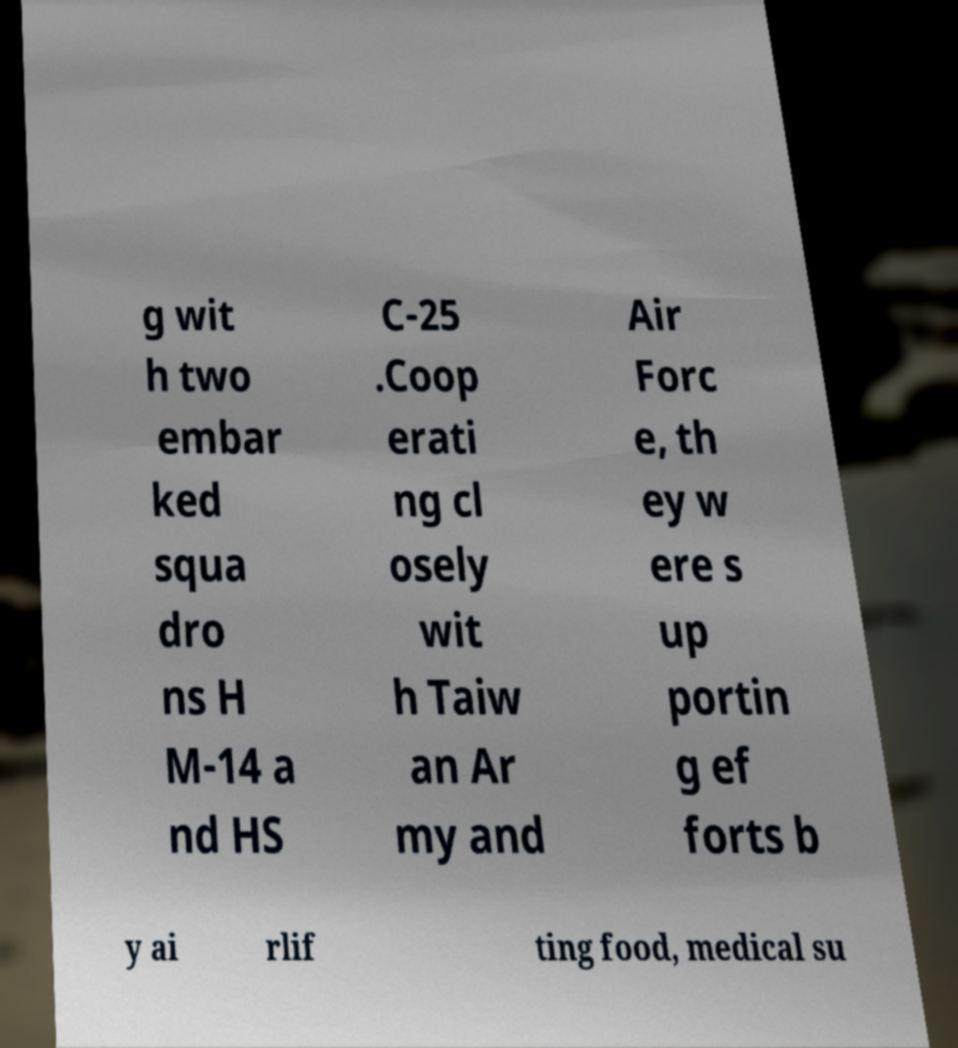I need the written content from this picture converted into text. Can you do that? g wit h two embar ked squa dro ns H M-14 a nd HS C-25 .Coop erati ng cl osely wit h Taiw an Ar my and Air Forc e, th ey w ere s up portin g ef forts b y ai rlif ting food, medical su 